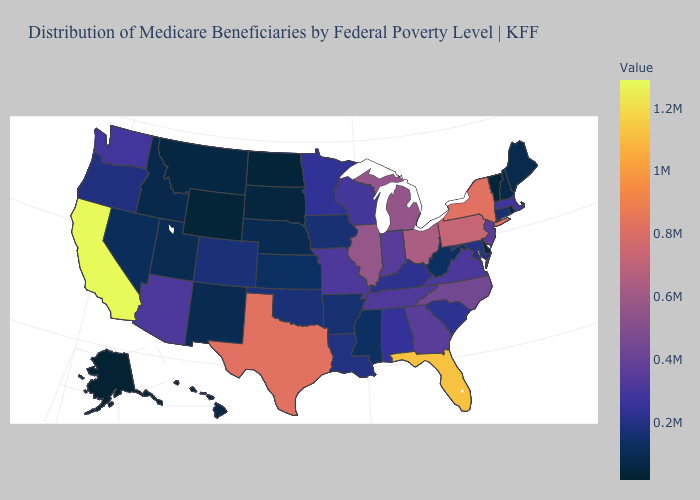Which states have the lowest value in the West?
Answer briefly. Alaska. Which states have the highest value in the USA?
Concise answer only. California. Which states have the lowest value in the USA?
Short answer required. Alaska. Which states have the lowest value in the South?
Write a very short answer. Delaware. Does California have the highest value in the West?
Give a very brief answer. Yes. Among the states that border Oklahoma , does New Mexico have the lowest value?
Be succinct. Yes. Does California have the highest value in the USA?
Answer briefly. Yes. Among the states that border Maryland , does Pennsylvania have the lowest value?
Give a very brief answer. No. 